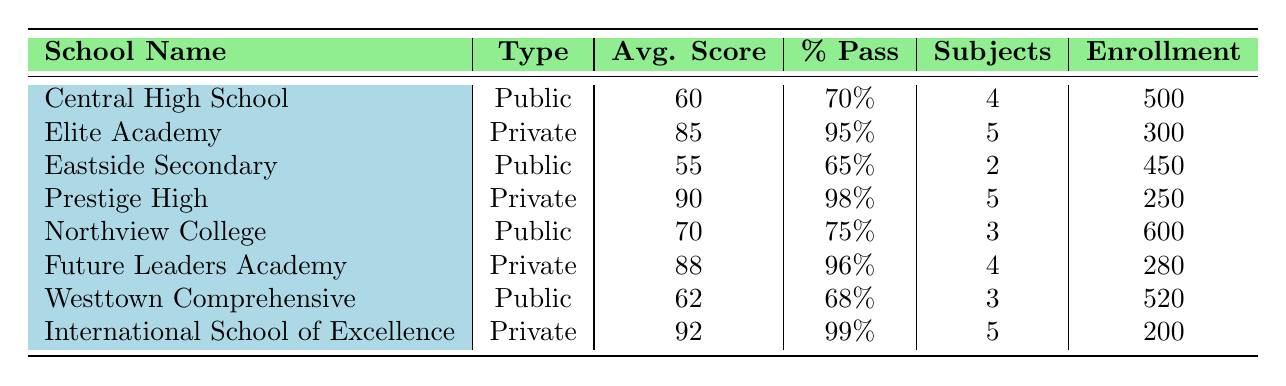What is the average score for public schools? To find the average score for public schools, we first identify the average scores for all public schools from the table: 60, 55, 70, and 62. We sum them up: 60 + 55 + 70 + 62 = 247. There are 4 public schools, so the average is 247 / 4 = 61.75.
Answer: 61.75 Which private school has the highest percent pass? By looking at the percent pass column for private schools, we find that Elite Academy has 95%, Prestige High has 98%, Future Leaders Academy has 96%, and International School of Excellence has 99%. The highest percent pass is 99%, held by International School of Excellence.
Answer: International School of Excellence How many unique subjects are offered across all schools? We need to list all the subjects offered in the table: Mathematics, English Language, Biology, Chemistry, Physics, Art, History, and Environmental Science. Counting these gives us 8 unique subjects.
Answer: 8 Is it true that Northview College has an average score greater than 65? Northview College has an average score of 70, which is greater than 65. Therefore, the statement is true.
Answer: Yes What is the difference in average scores between the top-performing private and public schools? The top-performing public school is Northview College with an average score of 70. The top-performing private school is International School of Excellence with an average score of 92. The difference in average scores is 92 - 70 = 22.
Answer: 22 How many students are enrolled in public schools altogether? The total enrollment in public schools can be found by adding the number of students from all public schools: 500 (Central High School) + 450 (Eastside Secondary) + 600 (Northview College) + 520 (Westtown Comprehensive) = 2070.
Answer: 2070 Are there any public schools that offer exactly three subjects? By examining the subjects offered, only Northview College and Westtown Comprehensive offer exactly three subjects. Therefore, the answer is yes, there are public schools with exactly three subjects.
Answer: Yes Which type of school has a higher average pass percentage? The average pass percentage for public schools is (70 + 65 + 75 + 68) / 4 = 69.5. For private schools, it is (95 + 98 + 96 + 99) / 4 = 97. Therefore, private schools have a higher average pass percentage.
Answer: Private schools 